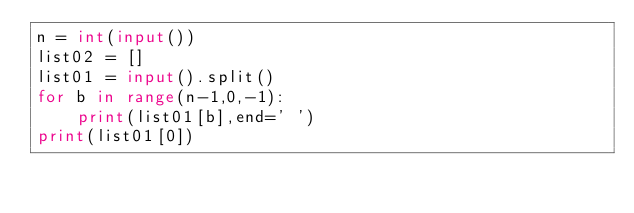Convert code to text. <code><loc_0><loc_0><loc_500><loc_500><_Python_>n = int(input())
list02 = []
list01 = input().split()
for b in range(n-1,0,-1):
    print(list01[b],end=' ')
print(list01[0])

</code> 